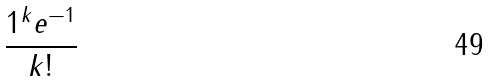Convert formula to latex. <formula><loc_0><loc_0><loc_500><loc_500>\frac { 1 ^ { k } e ^ { - 1 } } { k ! }</formula> 